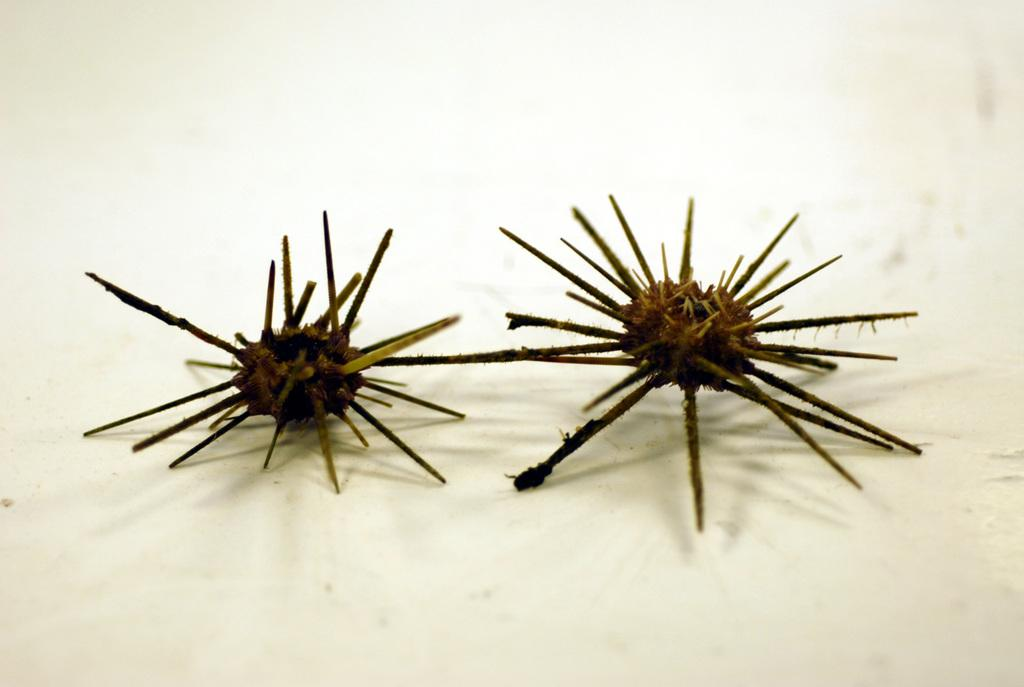What is located in the center of the image? There are objects in the center of the image. Can you describe the objects in the center of the image? Unfortunately, the provided facts do not give any details about the objects in the center of the image. What is at the bottom of the image? There is a wall at the bottom of the image. Can you tell me how many bees are flying around the stove in the image? There is no stove or bees present in the image. What type of bird can be seen perched on the wall in the image? There is no bird present in the image; only a wall is visible at the bottom. 